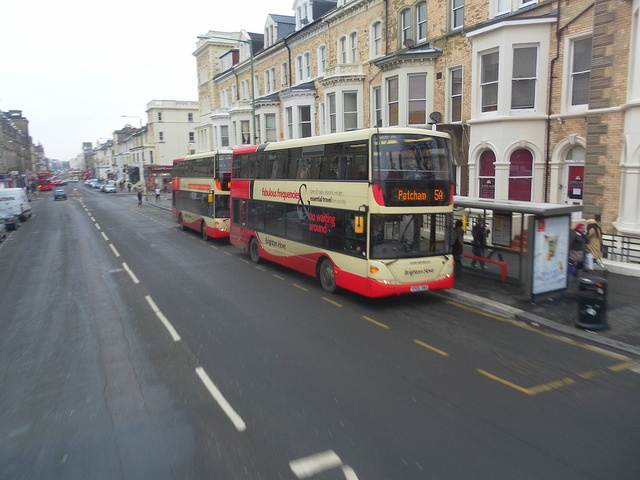Describe the objects in this image and their specific colors. I can see bus in white, black, gray, and tan tones, bus in white, gray, black, darkgray, and tan tones, truck in white, darkgray, gray, and lightblue tones, people in white, black, gray, and navy tones, and people in white, gray, black, and tan tones in this image. 